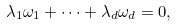Convert formula to latex. <formula><loc_0><loc_0><loc_500><loc_500>\lambda _ { 1 } \omega _ { 1 } + \cdots + \lambda _ { d } \omega _ { d } = 0 ,</formula> 